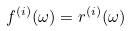<formula> <loc_0><loc_0><loc_500><loc_500>f ^ { ( i ) } ( \omega ) = r ^ { ( i ) } ( \omega )</formula> 